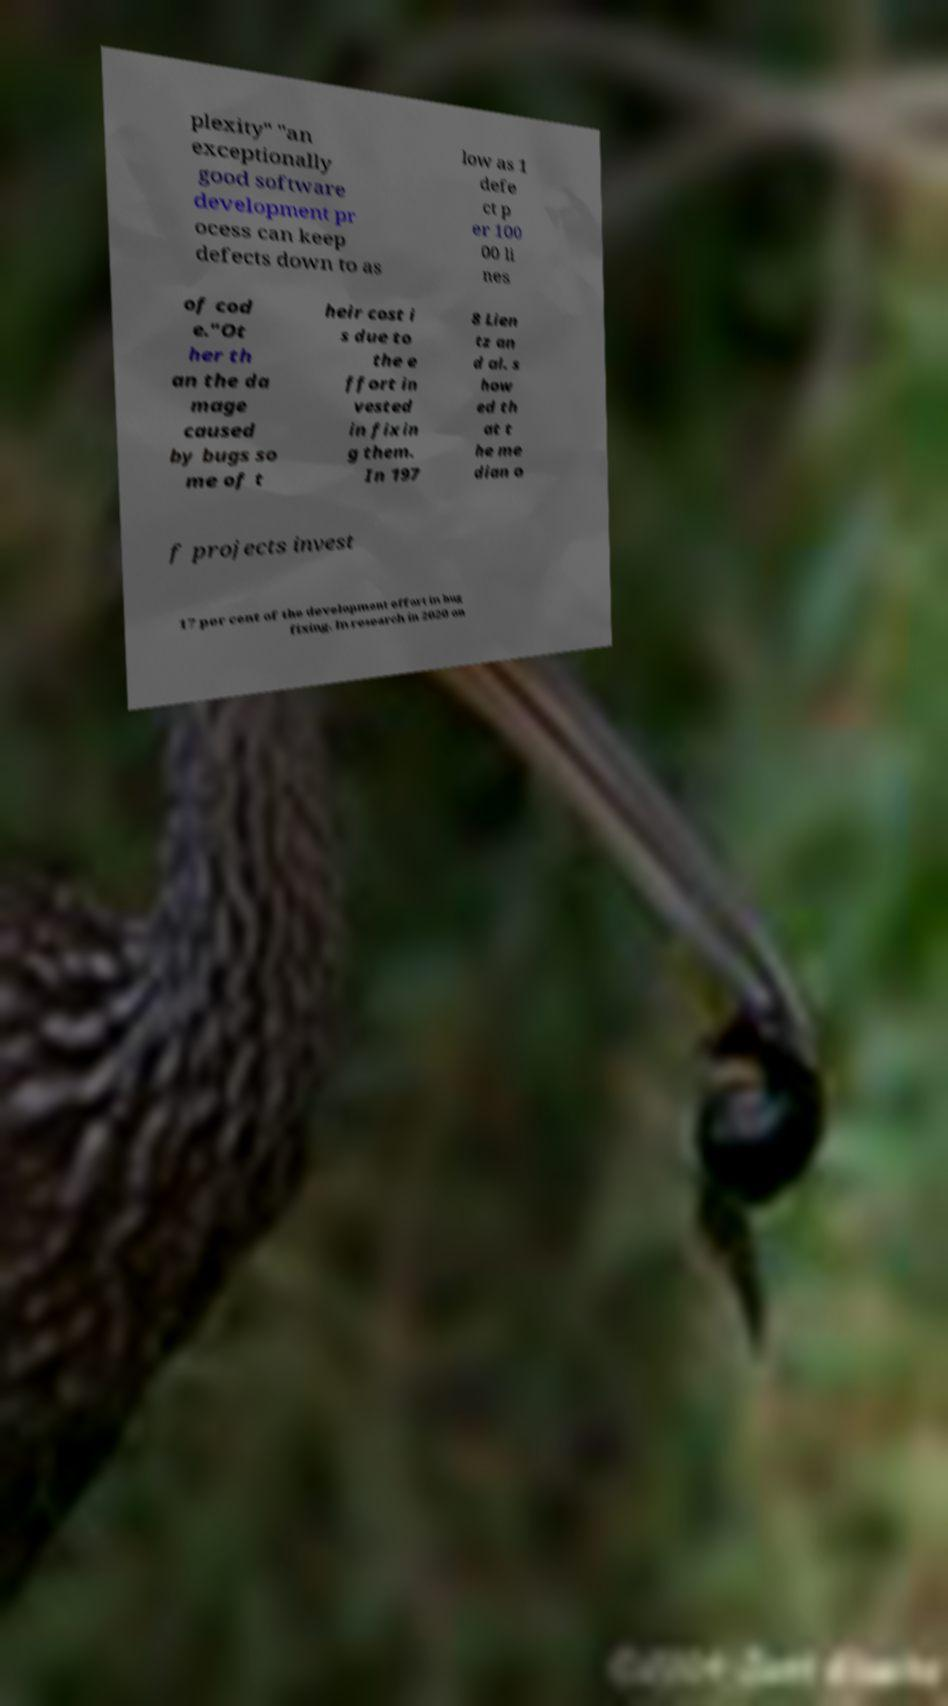There's text embedded in this image that I need extracted. Can you transcribe it verbatim? plexity" "an exceptionally good software development pr ocess can keep defects down to as low as 1 defe ct p er 100 00 li nes of cod e."Ot her th an the da mage caused by bugs so me of t heir cost i s due to the e ffort in vested in fixin g them. In 197 8 Lien tz an d al. s how ed th at t he me dian o f projects invest 17 per cent of the development effort in bug fixing. In research in 2020 on 